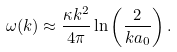<formula> <loc_0><loc_0><loc_500><loc_500>\omega ( k ) \approx \frac { \kappa k ^ { 2 } } { 4 \pi } \ln \left ( \frac { 2 } { k a _ { 0 } } \right ) .</formula> 